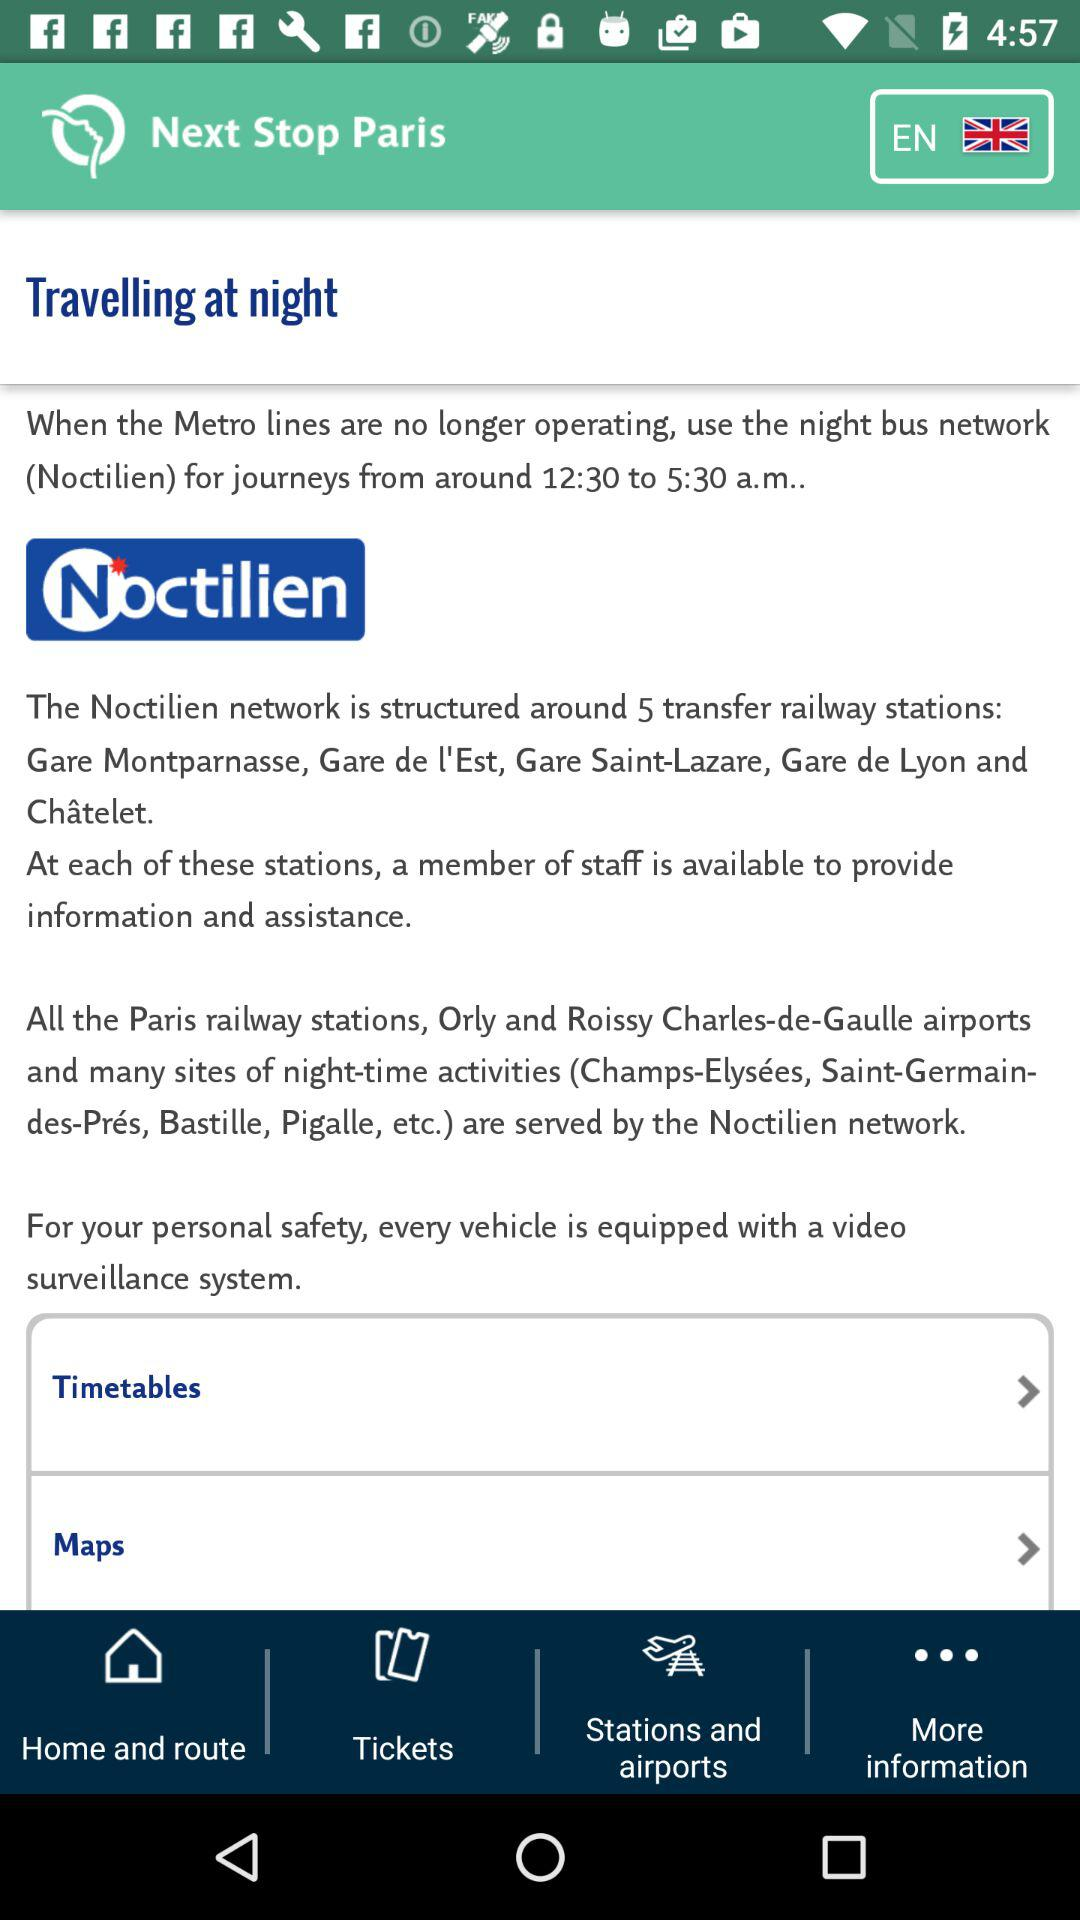What is the name of the application? The name of the application is "Next Stop Paris". 